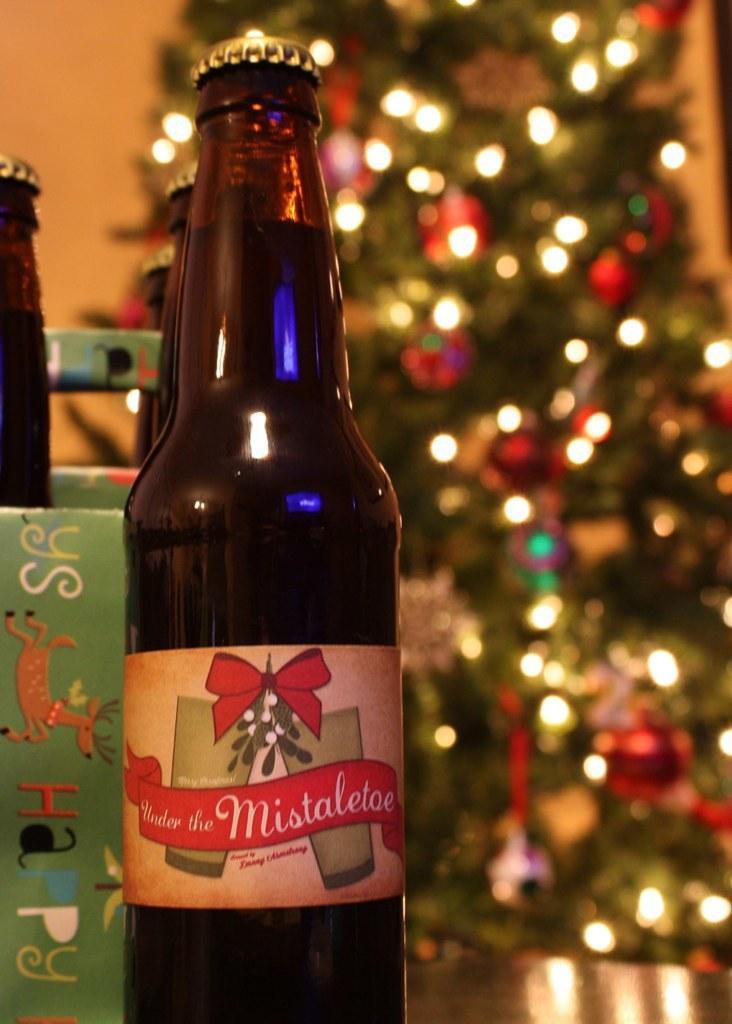In one or two sentences, can you explain what this image depicts? In this picture we can see few bottles, in the background we can find a tree with full of lights. 